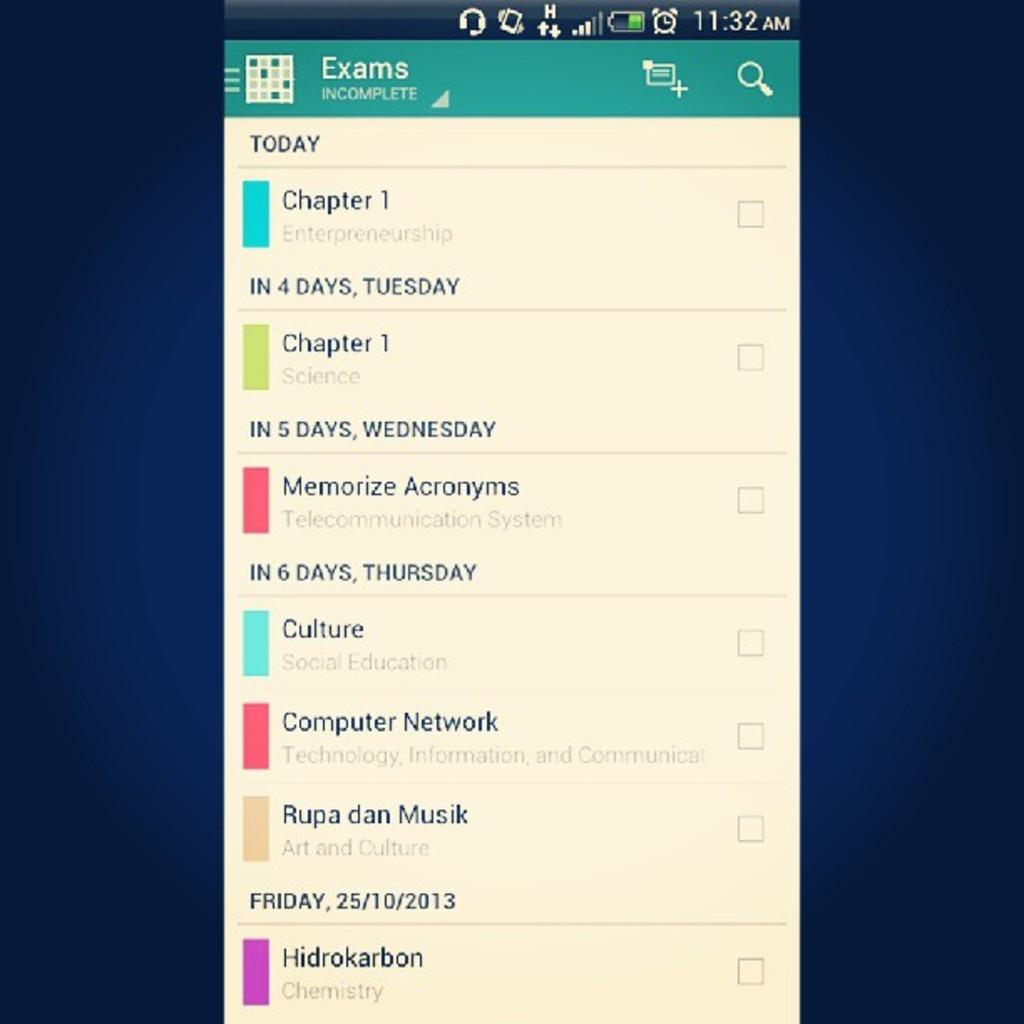<image>
Relay a brief, clear account of the picture shown. The mobile user interface shows a list of exams. 